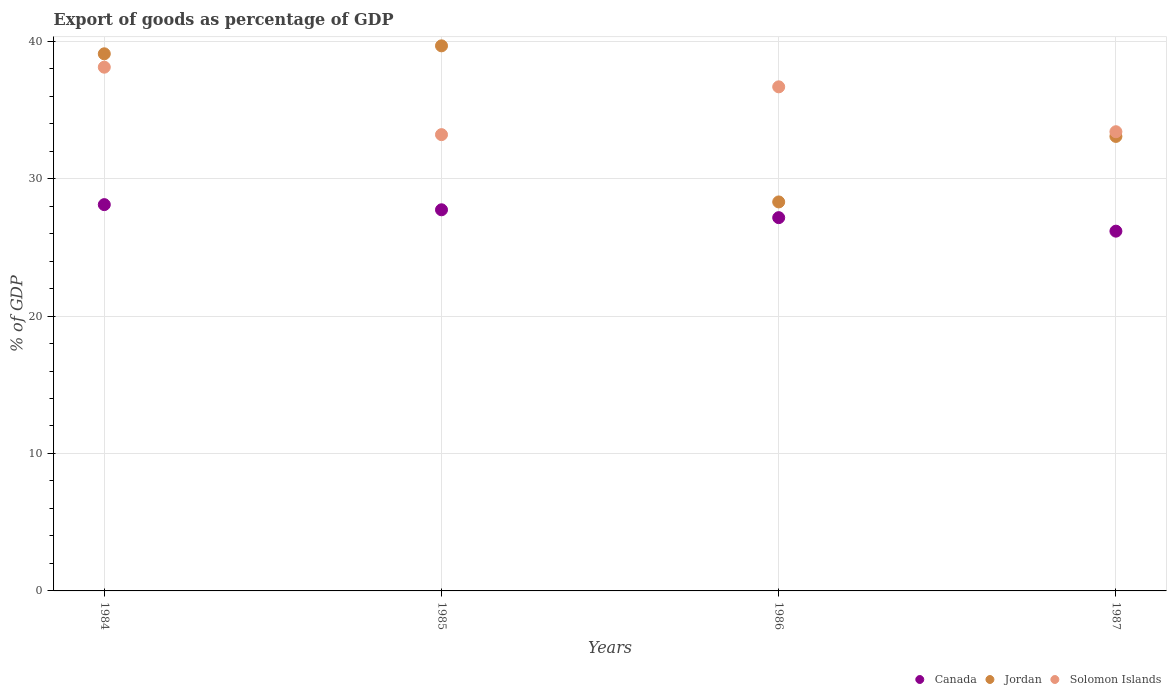How many different coloured dotlines are there?
Give a very brief answer. 3. What is the export of goods as percentage of GDP in Solomon Islands in 1986?
Ensure brevity in your answer.  36.68. Across all years, what is the maximum export of goods as percentage of GDP in Jordan?
Ensure brevity in your answer.  39.66. Across all years, what is the minimum export of goods as percentage of GDP in Solomon Islands?
Keep it short and to the point. 33.2. In which year was the export of goods as percentage of GDP in Solomon Islands maximum?
Your answer should be compact. 1984. What is the total export of goods as percentage of GDP in Canada in the graph?
Ensure brevity in your answer.  109.17. What is the difference between the export of goods as percentage of GDP in Jordan in 1985 and that in 1986?
Provide a succinct answer. 11.36. What is the difference between the export of goods as percentage of GDP in Jordan in 1986 and the export of goods as percentage of GDP in Solomon Islands in 1987?
Your answer should be very brief. -5.11. What is the average export of goods as percentage of GDP in Solomon Islands per year?
Keep it short and to the point. 35.35. In the year 1986, what is the difference between the export of goods as percentage of GDP in Solomon Islands and export of goods as percentage of GDP in Jordan?
Provide a short and direct response. 8.37. In how many years, is the export of goods as percentage of GDP in Jordan greater than 10 %?
Your answer should be very brief. 4. What is the ratio of the export of goods as percentage of GDP in Solomon Islands in 1984 to that in 1985?
Your answer should be compact. 1.15. Is the export of goods as percentage of GDP in Jordan in 1984 less than that in 1986?
Keep it short and to the point. No. Is the difference between the export of goods as percentage of GDP in Solomon Islands in 1984 and 1986 greater than the difference between the export of goods as percentage of GDP in Jordan in 1984 and 1986?
Offer a very short reply. No. What is the difference between the highest and the second highest export of goods as percentage of GDP in Jordan?
Your answer should be very brief. 0.58. What is the difference between the highest and the lowest export of goods as percentage of GDP in Canada?
Offer a very short reply. 1.93. In how many years, is the export of goods as percentage of GDP in Solomon Islands greater than the average export of goods as percentage of GDP in Solomon Islands taken over all years?
Your answer should be very brief. 2. Does the export of goods as percentage of GDP in Jordan monotonically increase over the years?
Keep it short and to the point. No. Is the export of goods as percentage of GDP in Solomon Islands strictly greater than the export of goods as percentage of GDP in Jordan over the years?
Offer a very short reply. No. Is the export of goods as percentage of GDP in Jordan strictly less than the export of goods as percentage of GDP in Canada over the years?
Offer a very short reply. No. How many years are there in the graph?
Ensure brevity in your answer.  4. Does the graph contain grids?
Provide a succinct answer. Yes. How are the legend labels stacked?
Your response must be concise. Horizontal. What is the title of the graph?
Keep it short and to the point. Export of goods as percentage of GDP. What is the label or title of the Y-axis?
Your answer should be compact. % of GDP. What is the % of GDP of Canada in 1984?
Ensure brevity in your answer.  28.11. What is the % of GDP in Jordan in 1984?
Make the answer very short. 39.08. What is the % of GDP in Solomon Islands in 1984?
Your response must be concise. 38.11. What is the % of GDP of Canada in 1985?
Provide a succinct answer. 27.73. What is the % of GDP in Jordan in 1985?
Your answer should be compact. 39.66. What is the % of GDP in Solomon Islands in 1985?
Offer a very short reply. 33.2. What is the % of GDP of Canada in 1986?
Your answer should be compact. 27.16. What is the % of GDP in Jordan in 1986?
Offer a very short reply. 28.3. What is the % of GDP of Solomon Islands in 1986?
Make the answer very short. 36.68. What is the % of GDP in Canada in 1987?
Provide a succinct answer. 26.18. What is the % of GDP of Jordan in 1987?
Make the answer very short. 33.07. What is the % of GDP of Solomon Islands in 1987?
Offer a very short reply. 33.41. Across all years, what is the maximum % of GDP of Canada?
Your answer should be very brief. 28.11. Across all years, what is the maximum % of GDP of Jordan?
Give a very brief answer. 39.66. Across all years, what is the maximum % of GDP in Solomon Islands?
Offer a terse response. 38.11. Across all years, what is the minimum % of GDP of Canada?
Give a very brief answer. 26.18. Across all years, what is the minimum % of GDP of Jordan?
Provide a short and direct response. 28.3. Across all years, what is the minimum % of GDP of Solomon Islands?
Your answer should be compact. 33.2. What is the total % of GDP in Canada in the graph?
Ensure brevity in your answer.  109.17. What is the total % of GDP of Jordan in the graph?
Your response must be concise. 140.11. What is the total % of GDP in Solomon Islands in the graph?
Ensure brevity in your answer.  141.39. What is the difference between the % of GDP in Canada in 1984 and that in 1985?
Ensure brevity in your answer.  0.38. What is the difference between the % of GDP of Jordan in 1984 and that in 1985?
Ensure brevity in your answer.  -0.58. What is the difference between the % of GDP of Solomon Islands in 1984 and that in 1985?
Your answer should be compact. 4.91. What is the difference between the % of GDP of Canada in 1984 and that in 1986?
Make the answer very short. 0.95. What is the difference between the % of GDP in Jordan in 1984 and that in 1986?
Your answer should be compact. 10.78. What is the difference between the % of GDP of Solomon Islands in 1984 and that in 1986?
Your answer should be compact. 1.43. What is the difference between the % of GDP in Canada in 1984 and that in 1987?
Provide a succinct answer. 1.93. What is the difference between the % of GDP in Jordan in 1984 and that in 1987?
Your response must be concise. 6.01. What is the difference between the % of GDP in Solomon Islands in 1984 and that in 1987?
Provide a succinct answer. 4.7. What is the difference between the % of GDP of Canada in 1985 and that in 1986?
Offer a very short reply. 0.57. What is the difference between the % of GDP in Jordan in 1985 and that in 1986?
Offer a very short reply. 11.36. What is the difference between the % of GDP in Solomon Islands in 1985 and that in 1986?
Offer a terse response. -3.48. What is the difference between the % of GDP in Canada in 1985 and that in 1987?
Make the answer very short. 1.55. What is the difference between the % of GDP in Jordan in 1985 and that in 1987?
Your response must be concise. 6.59. What is the difference between the % of GDP of Solomon Islands in 1985 and that in 1987?
Ensure brevity in your answer.  -0.21. What is the difference between the % of GDP in Canada in 1986 and that in 1987?
Your response must be concise. 0.98. What is the difference between the % of GDP of Jordan in 1986 and that in 1987?
Your answer should be very brief. -4.77. What is the difference between the % of GDP of Solomon Islands in 1986 and that in 1987?
Provide a short and direct response. 3.27. What is the difference between the % of GDP in Canada in 1984 and the % of GDP in Jordan in 1985?
Ensure brevity in your answer.  -11.55. What is the difference between the % of GDP in Canada in 1984 and the % of GDP in Solomon Islands in 1985?
Your answer should be compact. -5.09. What is the difference between the % of GDP of Jordan in 1984 and the % of GDP of Solomon Islands in 1985?
Provide a short and direct response. 5.88. What is the difference between the % of GDP in Canada in 1984 and the % of GDP in Jordan in 1986?
Your answer should be very brief. -0.2. What is the difference between the % of GDP of Canada in 1984 and the % of GDP of Solomon Islands in 1986?
Offer a very short reply. -8.57. What is the difference between the % of GDP in Jordan in 1984 and the % of GDP in Solomon Islands in 1986?
Make the answer very short. 2.4. What is the difference between the % of GDP of Canada in 1984 and the % of GDP of Jordan in 1987?
Your response must be concise. -4.96. What is the difference between the % of GDP of Canada in 1984 and the % of GDP of Solomon Islands in 1987?
Your answer should be very brief. -5.3. What is the difference between the % of GDP in Jordan in 1984 and the % of GDP in Solomon Islands in 1987?
Ensure brevity in your answer.  5.67. What is the difference between the % of GDP of Canada in 1985 and the % of GDP of Jordan in 1986?
Keep it short and to the point. -0.57. What is the difference between the % of GDP of Canada in 1985 and the % of GDP of Solomon Islands in 1986?
Offer a very short reply. -8.95. What is the difference between the % of GDP in Jordan in 1985 and the % of GDP in Solomon Islands in 1986?
Ensure brevity in your answer.  2.98. What is the difference between the % of GDP in Canada in 1985 and the % of GDP in Jordan in 1987?
Offer a very short reply. -5.34. What is the difference between the % of GDP in Canada in 1985 and the % of GDP in Solomon Islands in 1987?
Keep it short and to the point. -5.68. What is the difference between the % of GDP in Jordan in 1985 and the % of GDP in Solomon Islands in 1987?
Ensure brevity in your answer.  6.25. What is the difference between the % of GDP in Canada in 1986 and the % of GDP in Jordan in 1987?
Your answer should be very brief. -5.91. What is the difference between the % of GDP in Canada in 1986 and the % of GDP in Solomon Islands in 1987?
Provide a short and direct response. -6.25. What is the difference between the % of GDP in Jordan in 1986 and the % of GDP in Solomon Islands in 1987?
Your answer should be compact. -5.11. What is the average % of GDP of Canada per year?
Your answer should be compact. 27.29. What is the average % of GDP of Jordan per year?
Provide a succinct answer. 35.03. What is the average % of GDP in Solomon Islands per year?
Your answer should be compact. 35.35. In the year 1984, what is the difference between the % of GDP in Canada and % of GDP in Jordan?
Your answer should be compact. -10.97. In the year 1984, what is the difference between the % of GDP of Canada and % of GDP of Solomon Islands?
Keep it short and to the point. -10. In the year 1984, what is the difference between the % of GDP of Jordan and % of GDP of Solomon Islands?
Your response must be concise. 0.97. In the year 1985, what is the difference between the % of GDP of Canada and % of GDP of Jordan?
Keep it short and to the point. -11.93. In the year 1985, what is the difference between the % of GDP in Canada and % of GDP in Solomon Islands?
Your response must be concise. -5.47. In the year 1985, what is the difference between the % of GDP in Jordan and % of GDP in Solomon Islands?
Make the answer very short. 6.46. In the year 1986, what is the difference between the % of GDP in Canada and % of GDP in Jordan?
Keep it short and to the point. -1.14. In the year 1986, what is the difference between the % of GDP of Canada and % of GDP of Solomon Islands?
Provide a succinct answer. -9.52. In the year 1986, what is the difference between the % of GDP in Jordan and % of GDP in Solomon Islands?
Provide a succinct answer. -8.37. In the year 1987, what is the difference between the % of GDP in Canada and % of GDP in Jordan?
Provide a succinct answer. -6.89. In the year 1987, what is the difference between the % of GDP in Canada and % of GDP in Solomon Islands?
Keep it short and to the point. -7.23. In the year 1987, what is the difference between the % of GDP in Jordan and % of GDP in Solomon Islands?
Your response must be concise. -0.34. What is the ratio of the % of GDP of Canada in 1984 to that in 1985?
Provide a succinct answer. 1.01. What is the ratio of the % of GDP of Jordan in 1984 to that in 1985?
Make the answer very short. 0.99. What is the ratio of the % of GDP of Solomon Islands in 1984 to that in 1985?
Offer a terse response. 1.15. What is the ratio of the % of GDP of Canada in 1984 to that in 1986?
Your response must be concise. 1.03. What is the ratio of the % of GDP in Jordan in 1984 to that in 1986?
Provide a short and direct response. 1.38. What is the ratio of the % of GDP of Solomon Islands in 1984 to that in 1986?
Your answer should be compact. 1.04. What is the ratio of the % of GDP in Canada in 1984 to that in 1987?
Your response must be concise. 1.07. What is the ratio of the % of GDP in Jordan in 1984 to that in 1987?
Your answer should be very brief. 1.18. What is the ratio of the % of GDP of Solomon Islands in 1984 to that in 1987?
Ensure brevity in your answer.  1.14. What is the ratio of the % of GDP in Canada in 1985 to that in 1986?
Provide a short and direct response. 1.02. What is the ratio of the % of GDP in Jordan in 1985 to that in 1986?
Offer a very short reply. 1.4. What is the ratio of the % of GDP of Solomon Islands in 1985 to that in 1986?
Keep it short and to the point. 0.91. What is the ratio of the % of GDP in Canada in 1985 to that in 1987?
Your answer should be very brief. 1.06. What is the ratio of the % of GDP of Jordan in 1985 to that in 1987?
Your answer should be compact. 1.2. What is the ratio of the % of GDP of Canada in 1986 to that in 1987?
Provide a short and direct response. 1.04. What is the ratio of the % of GDP in Jordan in 1986 to that in 1987?
Make the answer very short. 0.86. What is the ratio of the % of GDP of Solomon Islands in 1986 to that in 1987?
Ensure brevity in your answer.  1.1. What is the difference between the highest and the second highest % of GDP in Canada?
Make the answer very short. 0.38. What is the difference between the highest and the second highest % of GDP of Jordan?
Give a very brief answer. 0.58. What is the difference between the highest and the second highest % of GDP of Solomon Islands?
Make the answer very short. 1.43. What is the difference between the highest and the lowest % of GDP in Canada?
Offer a very short reply. 1.93. What is the difference between the highest and the lowest % of GDP of Jordan?
Provide a short and direct response. 11.36. What is the difference between the highest and the lowest % of GDP in Solomon Islands?
Provide a short and direct response. 4.91. 